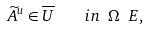<formula> <loc_0><loc_0><loc_500><loc_500>\widetilde { A } ^ { u } \in \overline { U } \quad i n \ \Omega \ E ,</formula> 